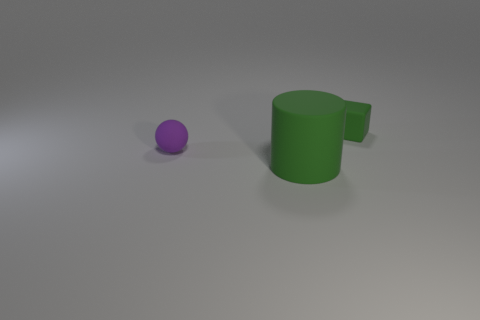There is a thing on the left side of the big object; does it have the same color as the cylinder?
Your answer should be compact. No. There is a green cylinder; are there any small blocks in front of it?
Your response must be concise. No. What is the color of the object that is on the right side of the purple matte thing and behind the big rubber cylinder?
Your response must be concise. Green. The matte object that is the same color as the cylinder is what shape?
Ensure brevity in your answer.  Cube. There is a matte thing behind the small matte object that is to the left of the block; what size is it?
Offer a very short reply. Small. How many cubes are big purple metal things or large objects?
Your answer should be compact. 0. What color is the rubber ball that is the same size as the green rubber block?
Make the answer very short. Purple. What is the shape of the matte thing that is in front of the small ball that is in front of the small green matte thing?
Give a very brief answer. Cylinder. There is a green object in front of the rubber block; does it have the same size as the purple matte sphere?
Provide a short and direct response. No. What number of other things are there of the same material as the cube
Keep it short and to the point. 2. 